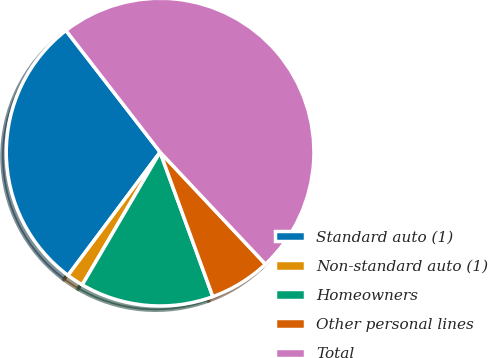Convert chart to OTSL. <chart><loc_0><loc_0><loc_500><loc_500><pie_chart><fcel>Standard auto (1)<fcel>Non-standard auto (1)<fcel>Homeowners<fcel>Other personal lines<fcel>Total<nl><fcel>29.3%<fcel>1.77%<fcel>14.01%<fcel>6.44%<fcel>48.47%<nl></chart> 